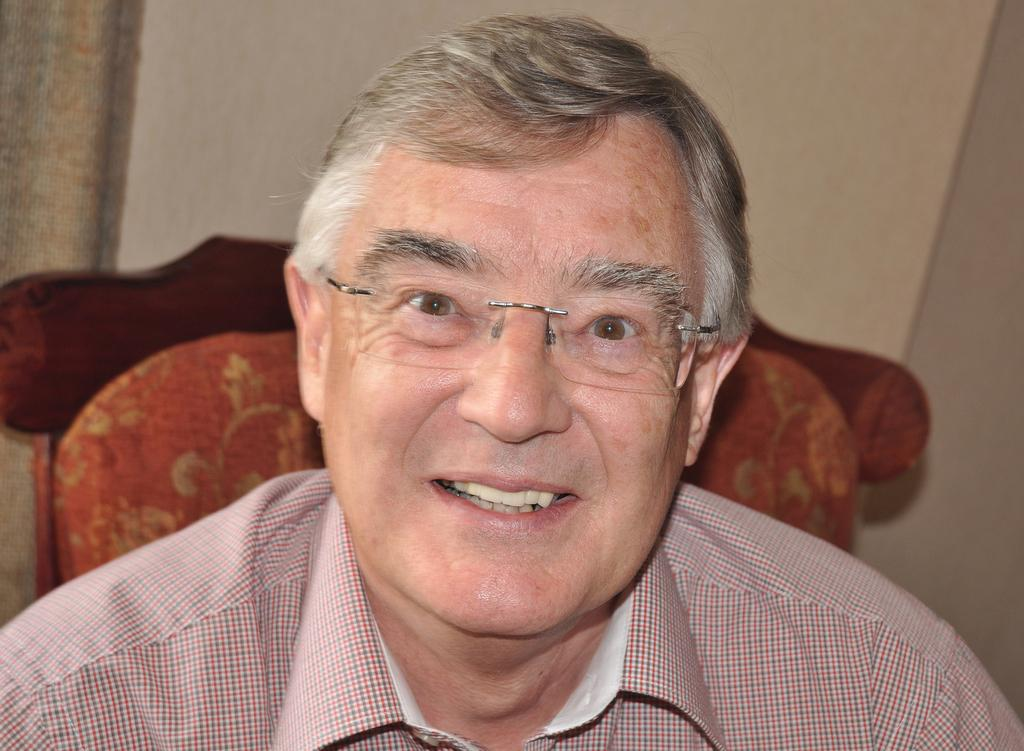What is the main subject of the image? There is a person in the image. What is the person wearing? The person is wearing a shirt and spectacles. What is the person's position in the image? The person is sitting on a chair. What can be seen in the background of the image? There is a wall in the background of the image. What is present on the left side of the image? There is a curtain on the left side of the image. How does the person in the image compare to a sense of smell? The person in the image is not being compared to a sense of smell, as the image only shows a person sitting on a chair. 